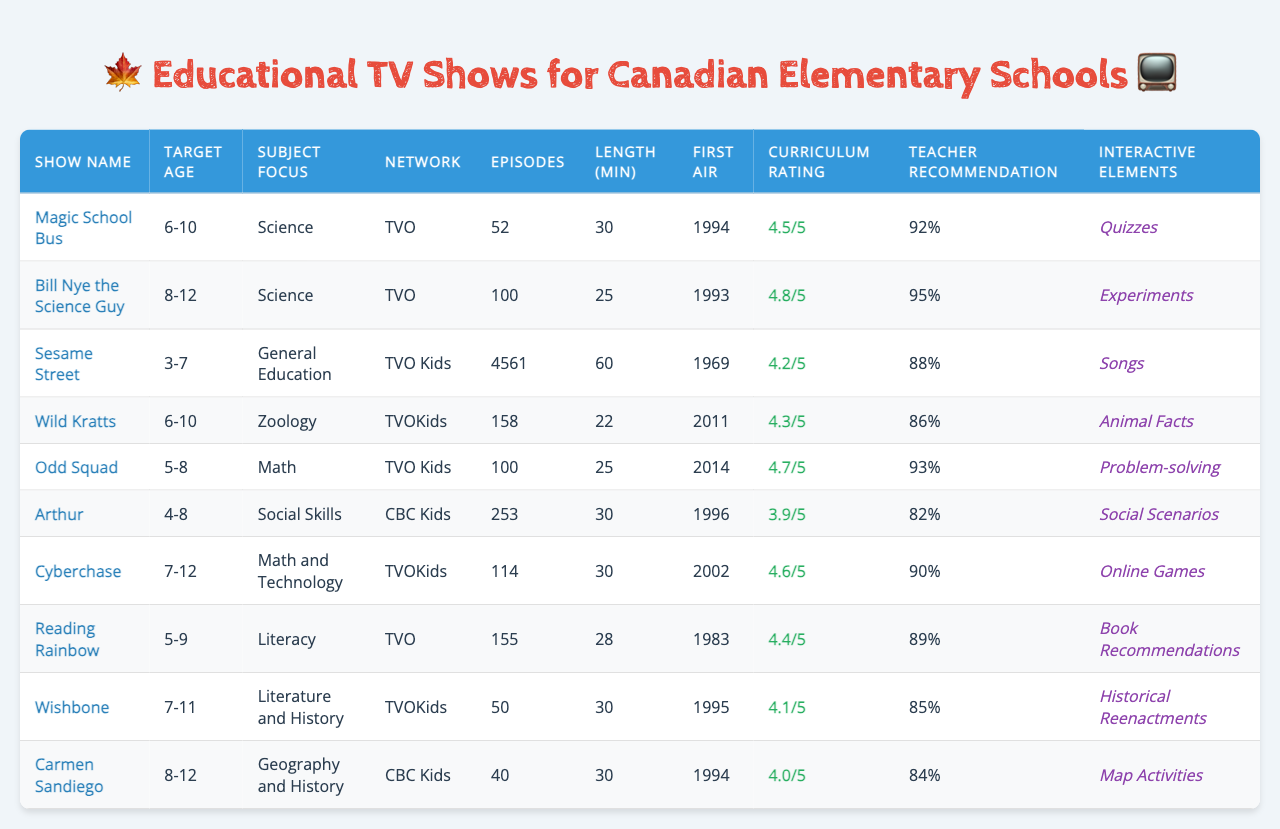What is the target age group for "Magic School Bus"? The table specifically lists the target age group for "Magic School Bus" as 6-10.
Answer: 6-10 Which show has the highest curriculum alignment rating? The ratings are listed in the table, and upon inspection, "Bill Nye the Science Guy" has the highest rating at 4.8.
Answer: 4.8 How many episodes are there in "Carmen Sandiego"? The table shows that "Carmen Sandiego" has a total of 40 episodes listed under the episodes count column.
Answer: 40 What interactive elements are associated with "Reading Rainbow"? The table indicates that "Reading Rainbow" includes interactive elements like Book Recommendations.
Answer: Book Recommendations Is "Arthur" aligned with any specific subjects? Yes, the table states that "Arthur" focuses on Social Skills as its subject area.
Answer: Yes How many shows target the age group of 6-10? The table lists two shows, "Magic School Bus" and "Wild Kratts," that target the age group of 6-10.
Answer: 2 What is the average episode length of "Wild Kratts"? The table specifies that the average episode length for "Wild Kratts" is 22 minutes.
Answer: 22 Which show has the lowest teacher recommendation percentage? When comparing the teacher recommendation percentages in the table, "Arthur" has the lowest at 82%.
Answer: 82 What is the total number of episodes across all shows? By summing the episodes count from each show, we find the total: 52 + 100 + 4561 + 158 + 100 + 253 + 114 + 155 + 50 + 40 = 5170 episodes in total.
Answer: 5170 Does any show focus specifically on Geography? Yes, "Carmen Sandiego" focuses on Geography and History according to the subject focus column.
Answer: Yes What is the difference in average episode length between "Bill Nye the Science Guy" and "Odd Squad"? "Bill Nye the Science Guy" has an average length of 25 minutes, while "Odd Squad" has 25 minutes too, so the difference is 0 minutes.
Answer: 0 Which show has the highest number of episodes and what is that number? The table shows that "Sesame Street" has the highest number of episodes, totaling 4561.
Answer: 4561 What percentage of teachers recommend "Cyberchase"? According to the table, the teacher recommendation percentage for "Cyberchase" is 90%.
Answer: 90 What is the curriculum alignment rating for "Wishbone"? The table specifies that "Wishbone" has a curriculum alignment rating of 4.1.
Answer: 4.1 Are there any shows that have the same first air year? Yes, both "Carmen Sandiego" and "Magic School Bus" first aired in 1994.
Answer: Yes What subject focus does "Wild Kratts" have? The table indicates that "Wild Kratts" focuses on Zoology.
Answer: Zoology 